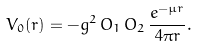<formula> <loc_0><loc_0><loc_500><loc_500>V _ { 0 } ( r ) = - g ^ { 2 } \, O _ { 1 } \, O _ { 2 } \, \frac { e ^ { - \mu r } } { 4 \pi r } .</formula> 